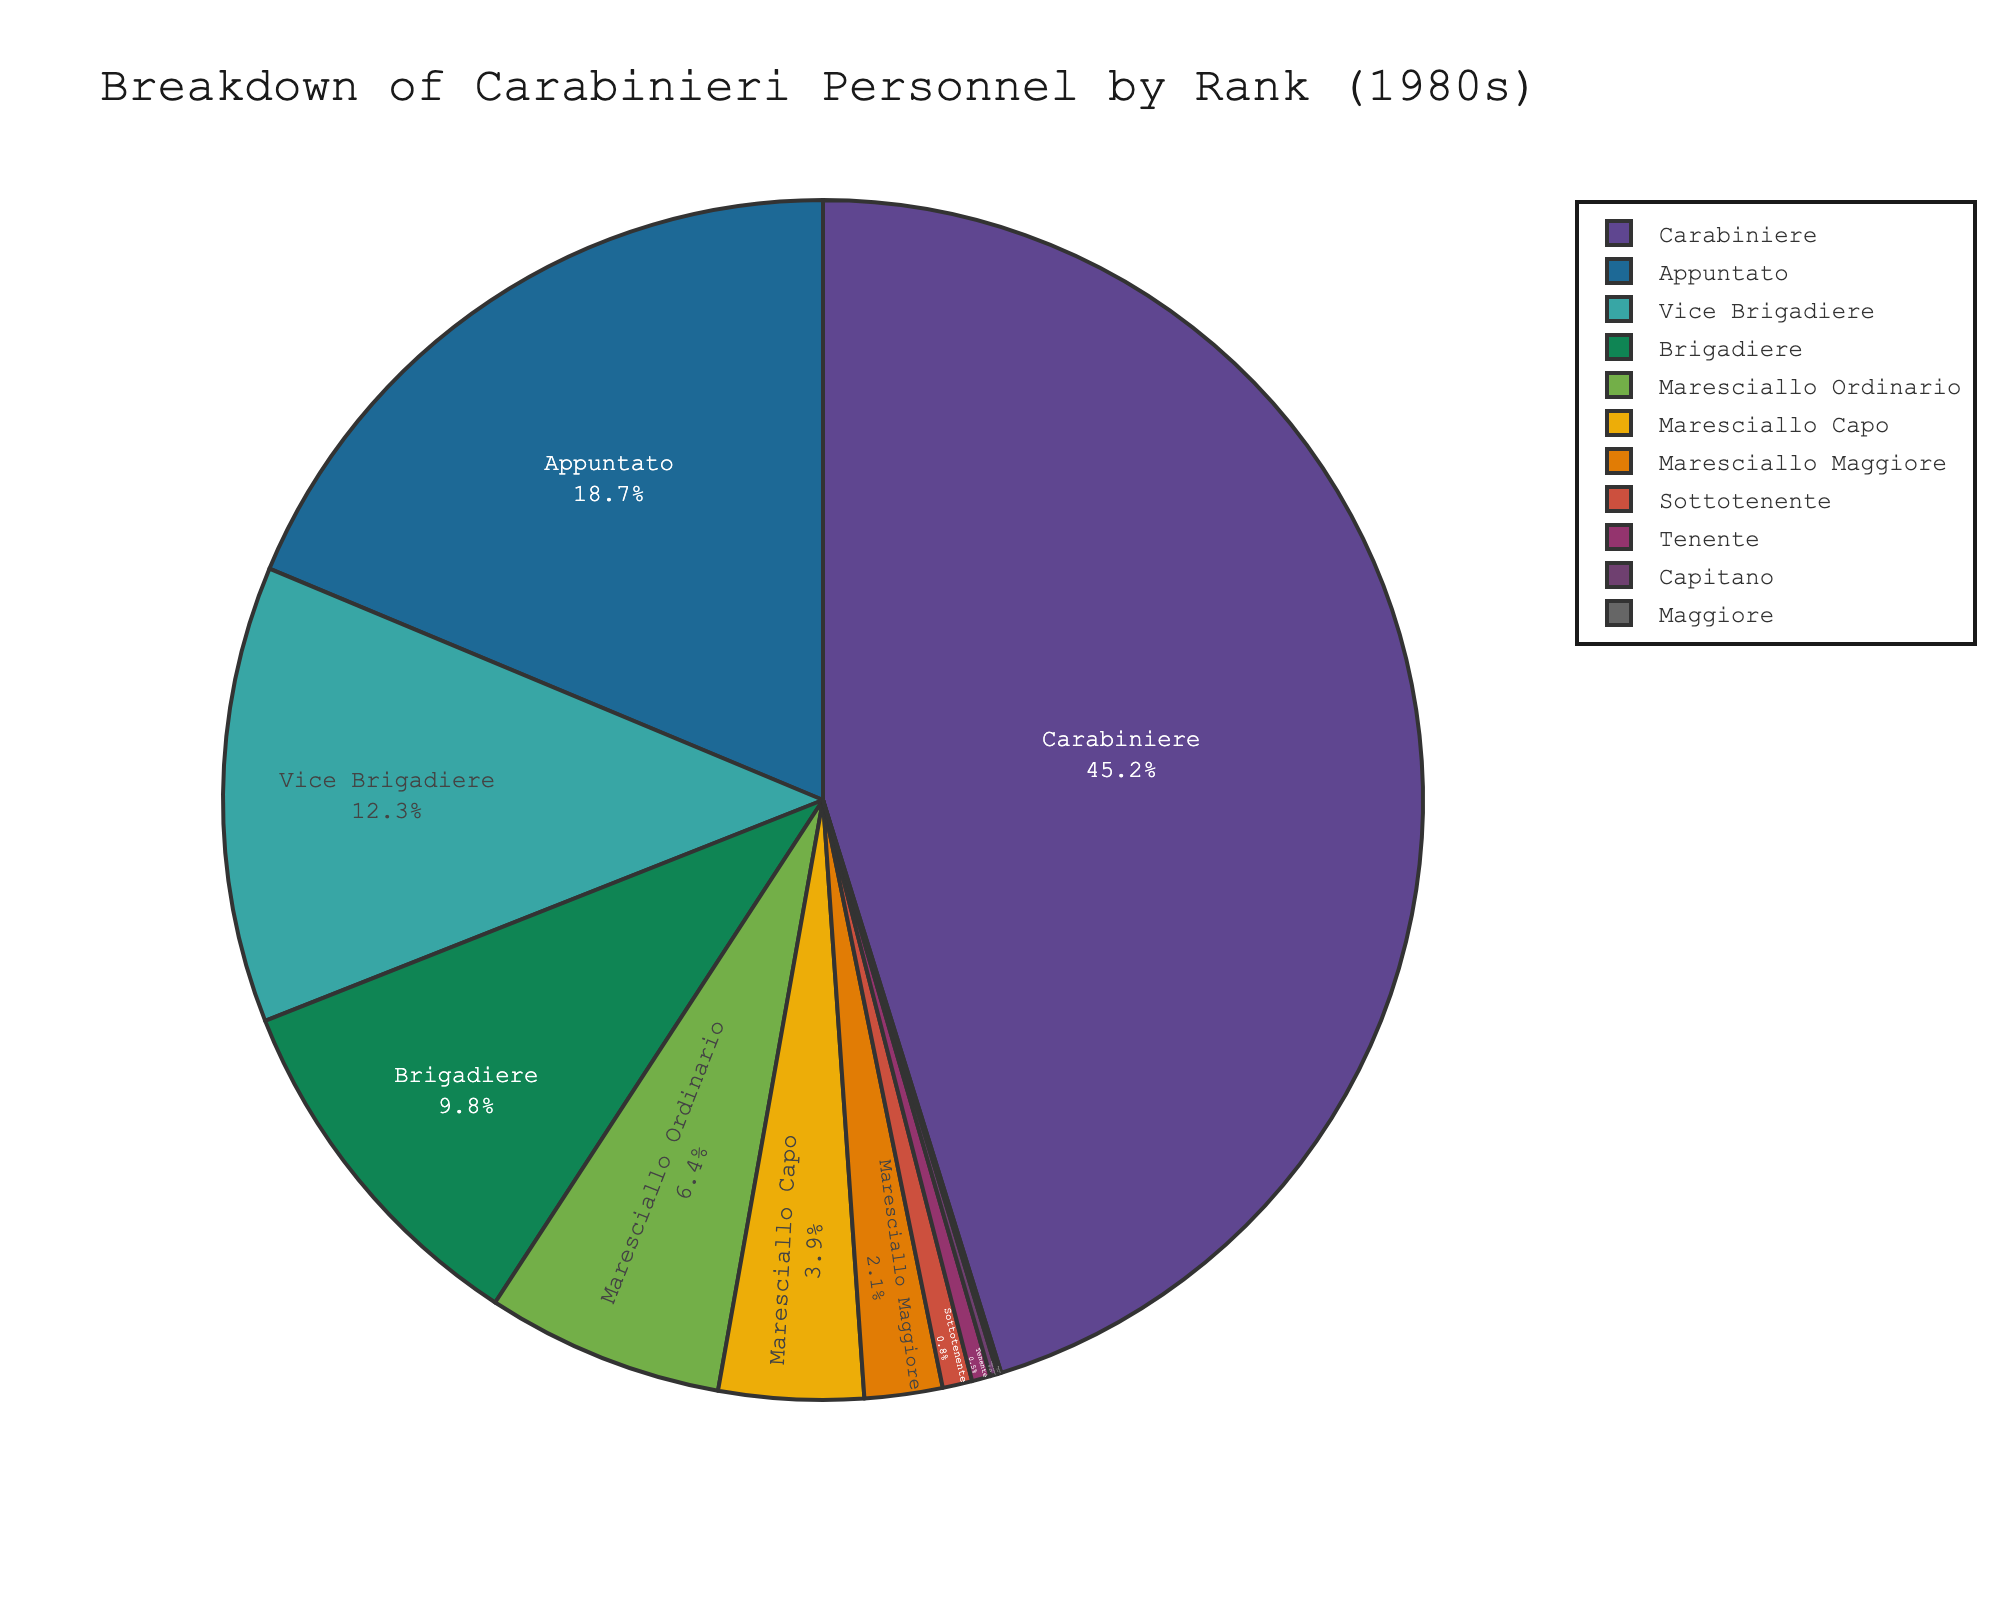Which rank has the largest percentage of personnel? The Carabiniere rank has the largest slice in the pie chart, indicating it has the highest percentage compared to other ranks.
Answer: Carabiniere What is the combined percentage of Vice Brigadiere and Brigadiere? Add the percentages for Vice Brigadiere (12.3%) and Brigadiere (9.8%) to find the total. 12.3 + 9.8 = 22.1
Answer: 22.1% Which rank has a higher percentage, Maresciallo Ordinario or Maresciallo Capo? By comparing both slices, Maresciallo Ordinario (6.4%) is larger than Maresciallo Capo (3.9%).
Answer: Maresciallo Ordinario What is the percentage difference between Appuntato and Sottotenente? Subtract the percentage of Sottotenente (0.8%) from Appuntato (18.7%) to find the difference. 18.7 - 0.8 = 17.9
Answer: 17.9% Which ranks have percentages less than 1% each? Observe the smallest slices in the pie chart: Sottotenente (0.8%), Tenente (0.5%), Capitano (0.2%), and Maggiore (0.1%).
Answer: Sottotenente, Tenente, Capitano, Maggiore What is the total percentage of all the ranks below Brigadiere? Add up the percentages for Carabiniere (45.2%), Appuntato (18.7%), and Vice Brigadiere (12.3%). 45.2 + 18.7 + 12.3 = 76.2
Answer: 76.2% Out of Maresciallo Capo and Maresciallo Maggiore, which rank has a smaller percentage and by how much? Compare the percentages: Maresciallo Capo (3.9%) and Maresciallo Maggiore (2.1%). Subtract them to find the difference: 3.9 - 2.1 = 1.8
Answer: Maresciallo Maggiore by 1.8% How many ranks together make up more than 70% of the personnel? Sum the largest percentages until exceeding 70%. Carabiniere (45.2%) + Appuntato (18.7%) + Vice Brigadiere (12.3%) sums to 76.2%, requiring three ranks.
Answer: 3 ranks 